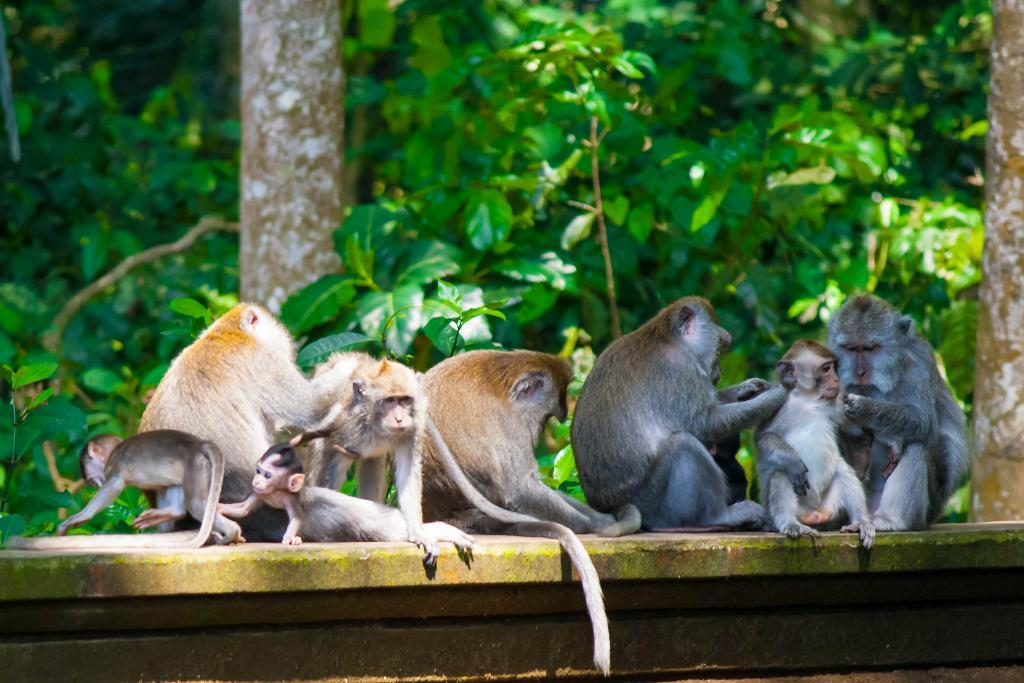What animals are present in the image? There is a group of monkeys in the image. Where are the monkeys located? The monkeys are sitting on a wall. What can be seen in the background of the image? There are trees in the background of the image. What type of farm can be seen in the image? There is no farm present in the image; it features a group of monkeys sitting on a wall with trees in the background. 